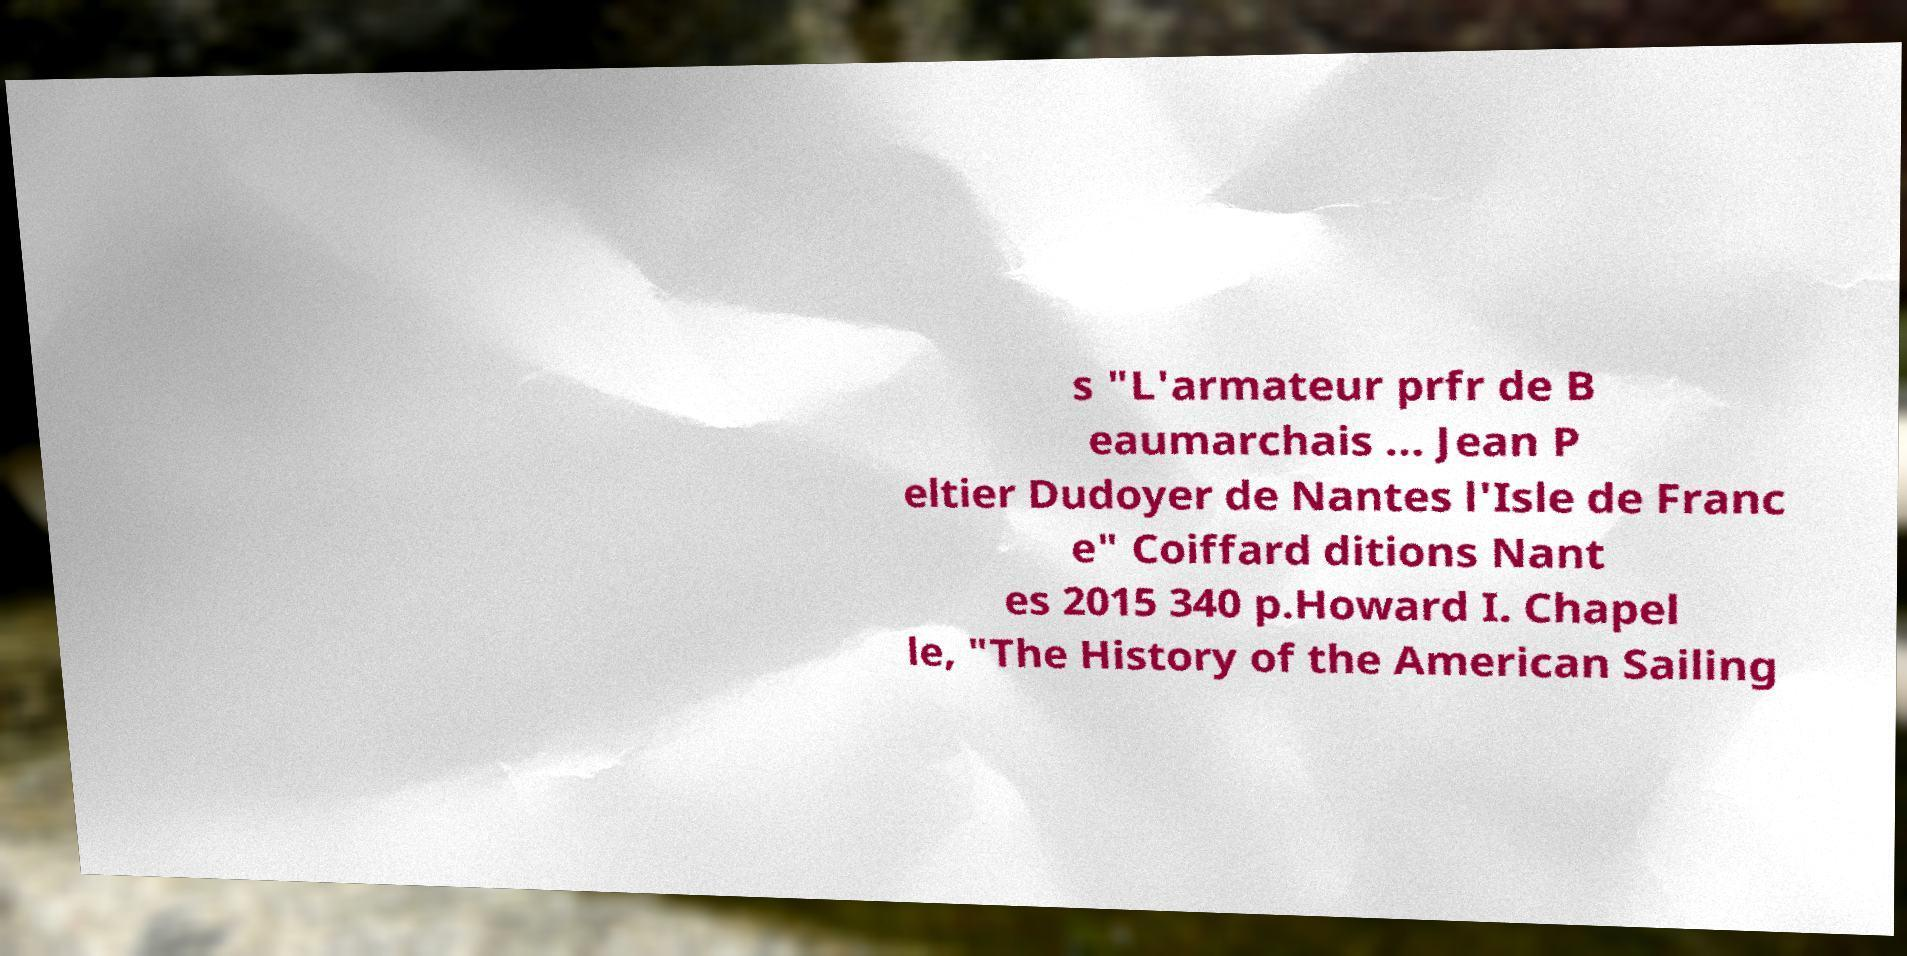For documentation purposes, I need the text within this image transcribed. Could you provide that? s "L'armateur prfr de B eaumarchais … Jean P eltier Dudoyer de Nantes l'Isle de Franc e" Coiffard ditions Nant es 2015 340 p.Howard I. Chapel le, "The History of the American Sailing 